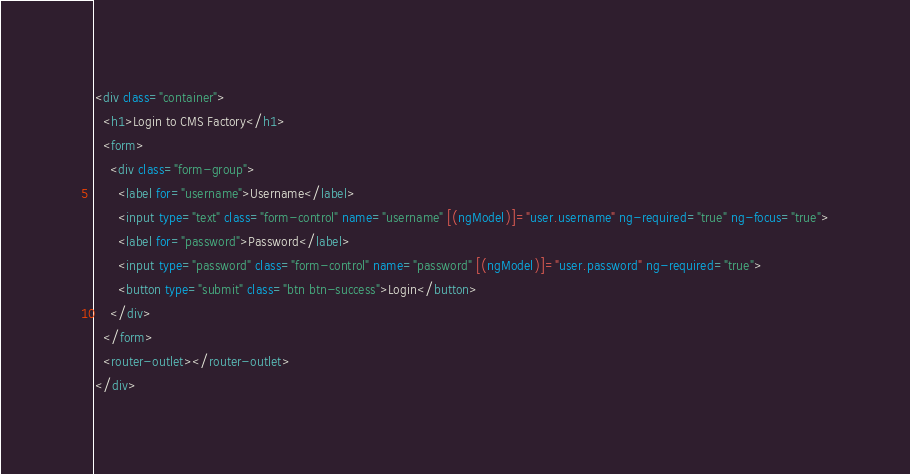<code> <loc_0><loc_0><loc_500><loc_500><_HTML_><div class="container">
  <h1>Login to CMS Factory</h1>
  <form>
    <div class="form-group">
      <label for="username">Username</label>
      <input type="text" class="form-control" name="username" [(ngModel)]="user.username" ng-required="true" ng-focus="true">
      <label for="password">Password</label>
      <input type="password" class="form-control" name="password" [(ngModel)]="user.password" ng-required="true">
      <button type="submit" class="btn btn-success">Login</button>
    </div>
  </form>
  <router-outlet></router-outlet>
</div></code> 